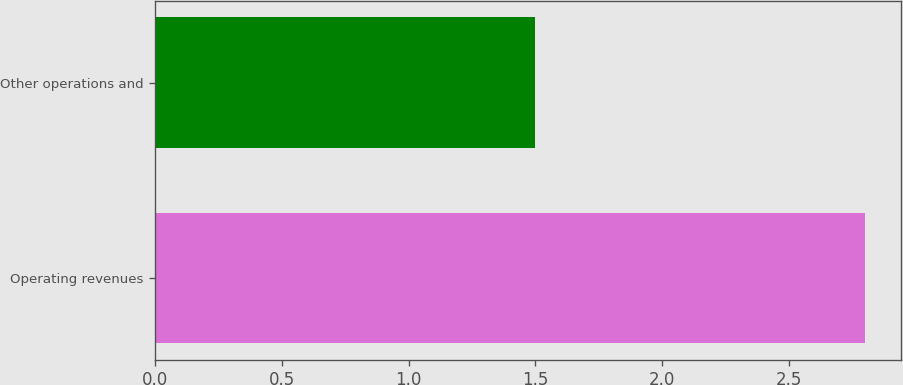Convert chart to OTSL. <chart><loc_0><loc_0><loc_500><loc_500><bar_chart><fcel>Operating revenues<fcel>Other operations and<nl><fcel>2.8<fcel>1.5<nl></chart> 